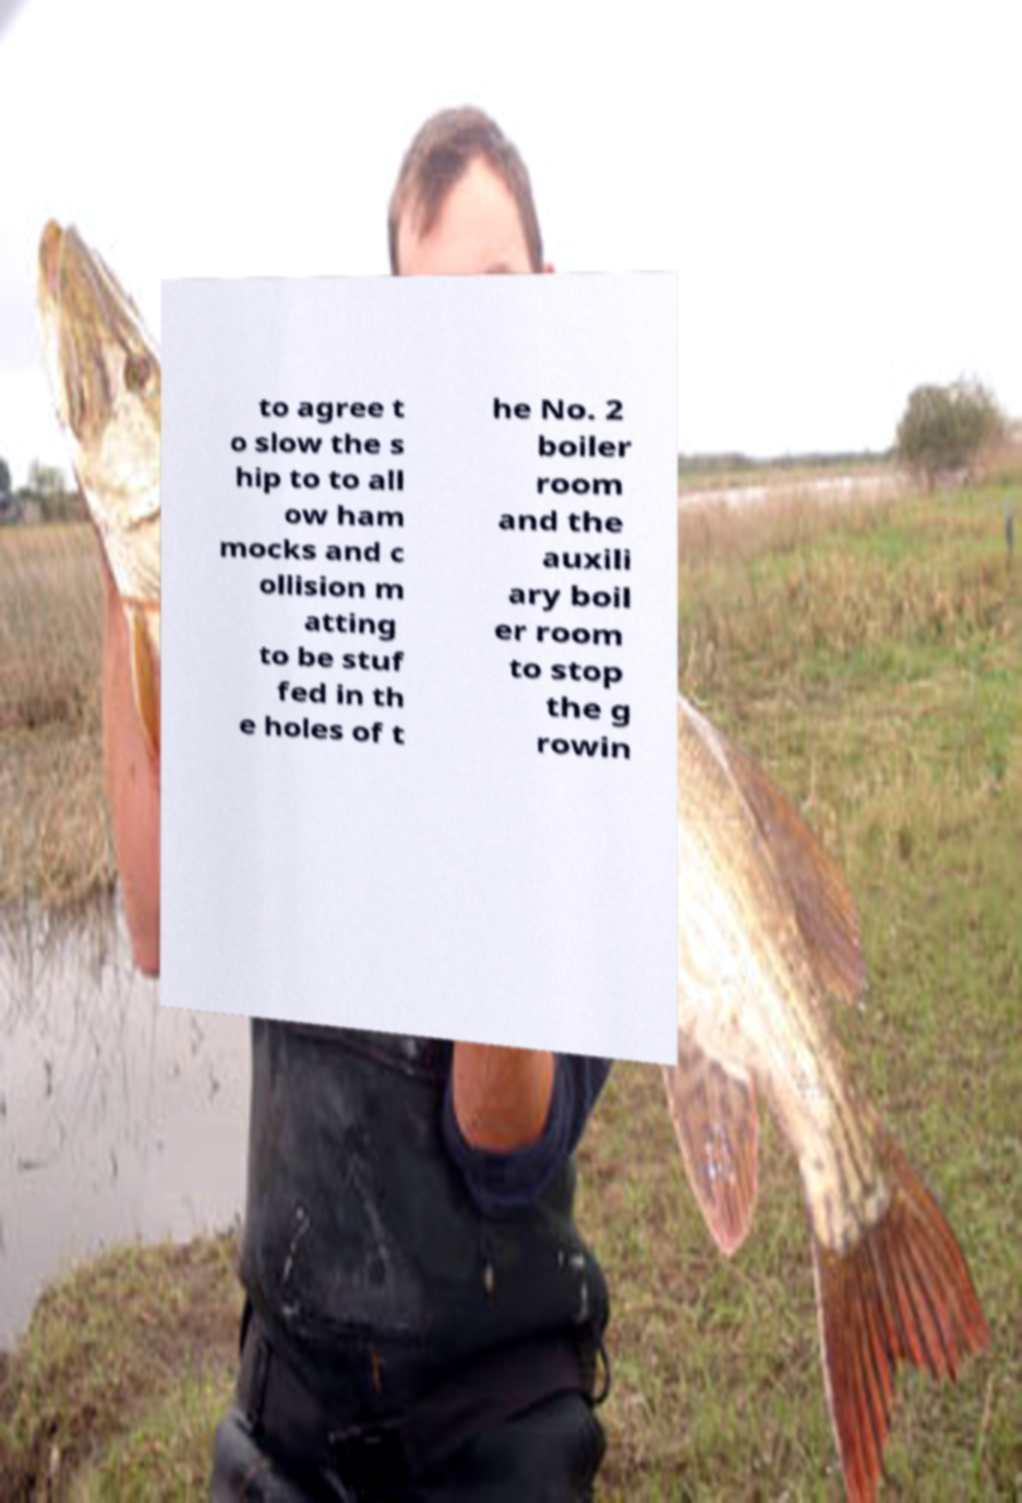For documentation purposes, I need the text within this image transcribed. Could you provide that? to agree t o slow the s hip to to all ow ham mocks and c ollision m atting to be stuf fed in th e holes of t he No. 2 boiler room and the auxili ary boil er room to stop the g rowin 